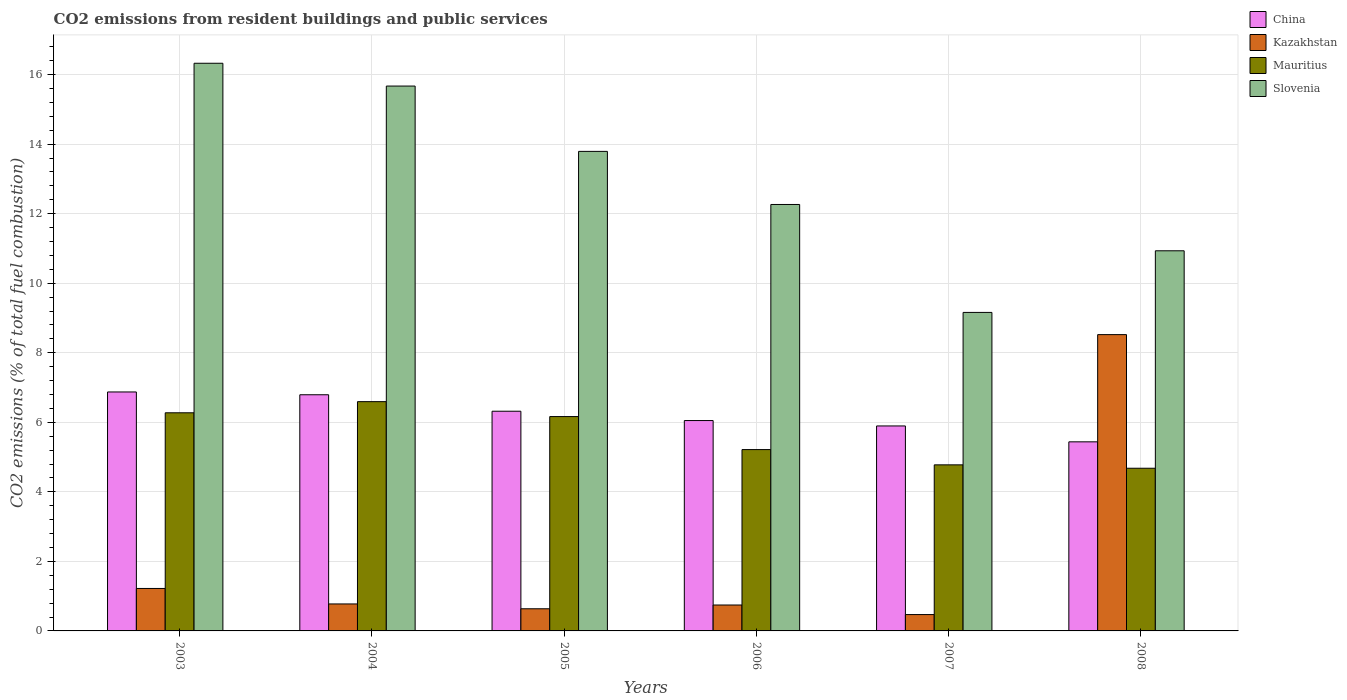How many groups of bars are there?
Your answer should be compact. 6. How many bars are there on the 5th tick from the left?
Your answer should be compact. 4. How many bars are there on the 4th tick from the right?
Your answer should be compact. 4. What is the total CO2 emitted in Mauritius in 2004?
Make the answer very short. 6.59. Across all years, what is the maximum total CO2 emitted in Slovenia?
Give a very brief answer. 16.33. Across all years, what is the minimum total CO2 emitted in Slovenia?
Your answer should be compact. 9.16. In which year was the total CO2 emitted in Kazakhstan minimum?
Keep it short and to the point. 2007. What is the total total CO2 emitted in China in the graph?
Ensure brevity in your answer.  37.36. What is the difference between the total CO2 emitted in Mauritius in 2005 and that in 2008?
Ensure brevity in your answer.  1.49. What is the difference between the total CO2 emitted in Kazakhstan in 2008 and the total CO2 emitted in Mauritius in 2004?
Your answer should be compact. 1.93. What is the average total CO2 emitted in China per year?
Offer a terse response. 6.23. In the year 2005, what is the difference between the total CO2 emitted in China and total CO2 emitted in Kazakhstan?
Keep it short and to the point. 5.68. In how many years, is the total CO2 emitted in Kazakhstan greater than 12.4?
Offer a terse response. 0. What is the ratio of the total CO2 emitted in Slovenia in 2006 to that in 2008?
Offer a terse response. 1.12. Is the total CO2 emitted in Mauritius in 2006 less than that in 2008?
Keep it short and to the point. No. Is the difference between the total CO2 emitted in China in 2004 and 2007 greater than the difference between the total CO2 emitted in Kazakhstan in 2004 and 2007?
Keep it short and to the point. Yes. What is the difference between the highest and the second highest total CO2 emitted in China?
Offer a very short reply. 0.08. What is the difference between the highest and the lowest total CO2 emitted in Slovenia?
Give a very brief answer. 7.17. Is it the case that in every year, the sum of the total CO2 emitted in Slovenia and total CO2 emitted in China is greater than the sum of total CO2 emitted in Kazakhstan and total CO2 emitted in Mauritius?
Provide a succinct answer. Yes. What does the 4th bar from the left in 2005 represents?
Give a very brief answer. Slovenia. What does the 3rd bar from the right in 2004 represents?
Keep it short and to the point. Kazakhstan. Is it the case that in every year, the sum of the total CO2 emitted in Kazakhstan and total CO2 emitted in Slovenia is greater than the total CO2 emitted in China?
Your response must be concise. Yes. Are all the bars in the graph horizontal?
Provide a short and direct response. No. How many years are there in the graph?
Make the answer very short. 6. Does the graph contain grids?
Ensure brevity in your answer.  Yes. What is the title of the graph?
Your answer should be very brief. CO2 emissions from resident buildings and public services. What is the label or title of the Y-axis?
Provide a short and direct response. CO2 emissions (% of total fuel combustion). What is the CO2 emissions (% of total fuel combustion) of China in 2003?
Make the answer very short. 6.87. What is the CO2 emissions (% of total fuel combustion) of Kazakhstan in 2003?
Keep it short and to the point. 1.22. What is the CO2 emissions (% of total fuel combustion) of Mauritius in 2003?
Provide a succinct answer. 6.27. What is the CO2 emissions (% of total fuel combustion) in Slovenia in 2003?
Offer a very short reply. 16.33. What is the CO2 emissions (% of total fuel combustion) of China in 2004?
Ensure brevity in your answer.  6.79. What is the CO2 emissions (% of total fuel combustion) in Kazakhstan in 2004?
Offer a terse response. 0.78. What is the CO2 emissions (% of total fuel combustion) in Mauritius in 2004?
Make the answer very short. 6.59. What is the CO2 emissions (% of total fuel combustion) in Slovenia in 2004?
Your response must be concise. 15.67. What is the CO2 emissions (% of total fuel combustion) of China in 2005?
Offer a very short reply. 6.32. What is the CO2 emissions (% of total fuel combustion) of Kazakhstan in 2005?
Ensure brevity in your answer.  0.64. What is the CO2 emissions (% of total fuel combustion) of Mauritius in 2005?
Make the answer very short. 6.16. What is the CO2 emissions (% of total fuel combustion) of Slovenia in 2005?
Provide a succinct answer. 13.79. What is the CO2 emissions (% of total fuel combustion) in China in 2006?
Your answer should be compact. 6.05. What is the CO2 emissions (% of total fuel combustion) of Kazakhstan in 2006?
Ensure brevity in your answer.  0.75. What is the CO2 emissions (% of total fuel combustion) of Mauritius in 2006?
Provide a succinct answer. 5.21. What is the CO2 emissions (% of total fuel combustion) of Slovenia in 2006?
Your response must be concise. 12.26. What is the CO2 emissions (% of total fuel combustion) of China in 2007?
Ensure brevity in your answer.  5.89. What is the CO2 emissions (% of total fuel combustion) in Kazakhstan in 2007?
Offer a terse response. 0.47. What is the CO2 emissions (% of total fuel combustion) in Mauritius in 2007?
Your answer should be very brief. 4.78. What is the CO2 emissions (% of total fuel combustion) in Slovenia in 2007?
Provide a succinct answer. 9.16. What is the CO2 emissions (% of total fuel combustion) in China in 2008?
Provide a succinct answer. 5.44. What is the CO2 emissions (% of total fuel combustion) of Kazakhstan in 2008?
Ensure brevity in your answer.  8.52. What is the CO2 emissions (% of total fuel combustion) in Mauritius in 2008?
Offer a terse response. 4.68. What is the CO2 emissions (% of total fuel combustion) in Slovenia in 2008?
Provide a short and direct response. 10.93. Across all years, what is the maximum CO2 emissions (% of total fuel combustion) in China?
Keep it short and to the point. 6.87. Across all years, what is the maximum CO2 emissions (% of total fuel combustion) in Kazakhstan?
Give a very brief answer. 8.52. Across all years, what is the maximum CO2 emissions (% of total fuel combustion) in Mauritius?
Ensure brevity in your answer.  6.59. Across all years, what is the maximum CO2 emissions (% of total fuel combustion) in Slovenia?
Provide a succinct answer. 16.33. Across all years, what is the minimum CO2 emissions (% of total fuel combustion) of China?
Offer a very short reply. 5.44. Across all years, what is the minimum CO2 emissions (% of total fuel combustion) of Kazakhstan?
Your answer should be compact. 0.47. Across all years, what is the minimum CO2 emissions (% of total fuel combustion) of Mauritius?
Provide a short and direct response. 4.68. Across all years, what is the minimum CO2 emissions (% of total fuel combustion) of Slovenia?
Make the answer very short. 9.16. What is the total CO2 emissions (% of total fuel combustion) of China in the graph?
Offer a very short reply. 37.36. What is the total CO2 emissions (% of total fuel combustion) of Kazakhstan in the graph?
Provide a short and direct response. 12.37. What is the total CO2 emissions (% of total fuel combustion) in Mauritius in the graph?
Offer a terse response. 33.7. What is the total CO2 emissions (% of total fuel combustion) of Slovenia in the graph?
Keep it short and to the point. 78.14. What is the difference between the CO2 emissions (% of total fuel combustion) of China in 2003 and that in 2004?
Your response must be concise. 0.08. What is the difference between the CO2 emissions (% of total fuel combustion) in Kazakhstan in 2003 and that in 2004?
Offer a very short reply. 0.45. What is the difference between the CO2 emissions (% of total fuel combustion) in Mauritius in 2003 and that in 2004?
Make the answer very short. -0.32. What is the difference between the CO2 emissions (% of total fuel combustion) of Slovenia in 2003 and that in 2004?
Your answer should be compact. 0.66. What is the difference between the CO2 emissions (% of total fuel combustion) in China in 2003 and that in 2005?
Provide a short and direct response. 0.55. What is the difference between the CO2 emissions (% of total fuel combustion) of Kazakhstan in 2003 and that in 2005?
Offer a terse response. 0.58. What is the difference between the CO2 emissions (% of total fuel combustion) in Mauritius in 2003 and that in 2005?
Make the answer very short. 0.11. What is the difference between the CO2 emissions (% of total fuel combustion) in Slovenia in 2003 and that in 2005?
Your response must be concise. 2.53. What is the difference between the CO2 emissions (% of total fuel combustion) of China in 2003 and that in 2006?
Your answer should be compact. 0.82. What is the difference between the CO2 emissions (% of total fuel combustion) of Kazakhstan in 2003 and that in 2006?
Your answer should be very brief. 0.48. What is the difference between the CO2 emissions (% of total fuel combustion) in Mauritius in 2003 and that in 2006?
Your answer should be compact. 1.06. What is the difference between the CO2 emissions (% of total fuel combustion) in Slovenia in 2003 and that in 2006?
Make the answer very short. 4.06. What is the difference between the CO2 emissions (% of total fuel combustion) in China in 2003 and that in 2007?
Keep it short and to the point. 0.98. What is the difference between the CO2 emissions (% of total fuel combustion) in Kazakhstan in 2003 and that in 2007?
Your answer should be very brief. 0.75. What is the difference between the CO2 emissions (% of total fuel combustion) in Mauritius in 2003 and that in 2007?
Ensure brevity in your answer.  1.5. What is the difference between the CO2 emissions (% of total fuel combustion) in Slovenia in 2003 and that in 2007?
Your response must be concise. 7.17. What is the difference between the CO2 emissions (% of total fuel combustion) in China in 2003 and that in 2008?
Your answer should be compact. 1.43. What is the difference between the CO2 emissions (% of total fuel combustion) in Kazakhstan in 2003 and that in 2008?
Offer a terse response. -7.3. What is the difference between the CO2 emissions (% of total fuel combustion) of Mauritius in 2003 and that in 2008?
Offer a very short reply. 1.59. What is the difference between the CO2 emissions (% of total fuel combustion) in Slovenia in 2003 and that in 2008?
Your answer should be very brief. 5.39. What is the difference between the CO2 emissions (% of total fuel combustion) in China in 2004 and that in 2005?
Make the answer very short. 0.47. What is the difference between the CO2 emissions (% of total fuel combustion) in Kazakhstan in 2004 and that in 2005?
Offer a very short reply. 0.14. What is the difference between the CO2 emissions (% of total fuel combustion) of Mauritius in 2004 and that in 2005?
Your response must be concise. 0.43. What is the difference between the CO2 emissions (% of total fuel combustion) in Slovenia in 2004 and that in 2005?
Provide a succinct answer. 1.88. What is the difference between the CO2 emissions (% of total fuel combustion) in China in 2004 and that in 2006?
Offer a very short reply. 0.74. What is the difference between the CO2 emissions (% of total fuel combustion) in Kazakhstan in 2004 and that in 2006?
Provide a short and direct response. 0.03. What is the difference between the CO2 emissions (% of total fuel combustion) in Mauritius in 2004 and that in 2006?
Give a very brief answer. 1.38. What is the difference between the CO2 emissions (% of total fuel combustion) in Slovenia in 2004 and that in 2006?
Ensure brevity in your answer.  3.41. What is the difference between the CO2 emissions (% of total fuel combustion) in China in 2004 and that in 2007?
Your answer should be very brief. 0.9. What is the difference between the CO2 emissions (% of total fuel combustion) in Kazakhstan in 2004 and that in 2007?
Give a very brief answer. 0.31. What is the difference between the CO2 emissions (% of total fuel combustion) of Mauritius in 2004 and that in 2007?
Offer a terse response. 1.82. What is the difference between the CO2 emissions (% of total fuel combustion) in Slovenia in 2004 and that in 2007?
Provide a succinct answer. 6.51. What is the difference between the CO2 emissions (% of total fuel combustion) in China in 2004 and that in 2008?
Give a very brief answer. 1.35. What is the difference between the CO2 emissions (% of total fuel combustion) of Kazakhstan in 2004 and that in 2008?
Give a very brief answer. -7.75. What is the difference between the CO2 emissions (% of total fuel combustion) of Mauritius in 2004 and that in 2008?
Provide a succinct answer. 1.92. What is the difference between the CO2 emissions (% of total fuel combustion) in Slovenia in 2004 and that in 2008?
Your answer should be very brief. 4.74. What is the difference between the CO2 emissions (% of total fuel combustion) in China in 2005 and that in 2006?
Give a very brief answer. 0.27. What is the difference between the CO2 emissions (% of total fuel combustion) of Kazakhstan in 2005 and that in 2006?
Your answer should be compact. -0.11. What is the difference between the CO2 emissions (% of total fuel combustion) of Mauritius in 2005 and that in 2006?
Your answer should be very brief. 0.95. What is the difference between the CO2 emissions (% of total fuel combustion) of Slovenia in 2005 and that in 2006?
Your answer should be compact. 1.53. What is the difference between the CO2 emissions (% of total fuel combustion) in China in 2005 and that in 2007?
Offer a very short reply. 0.42. What is the difference between the CO2 emissions (% of total fuel combustion) in Kazakhstan in 2005 and that in 2007?
Your answer should be compact. 0.17. What is the difference between the CO2 emissions (% of total fuel combustion) in Mauritius in 2005 and that in 2007?
Ensure brevity in your answer.  1.39. What is the difference between the CO2 emissions (% of total fuel combustion) in Slovenia in 2005 and that in 2007?
Make the answer very short. 4.63. What is the difference between the CO2 emissions (% of total fuel combustion) in China in 2005 and that in 2008?
Your answer should be compact. 0.88. What is the difference between the CO2 emissions (% of total fuel combustion) in Kazakhstan in 2005 and that in 2008?
Provide a short and direct response. -7.88. What is the difference between the CO2 emissions (% of total fuel combustion) in Mauritius in 2005 and that in 2008?
Make the answer very short. 1.49. What is the difference between the CO2 emissions (% of total fuel combustion) of Slovenia in 2005 and that in 2008?
Your response must be concise. 2.86. What is the difference between the CO2 emissions (% of total fuel combustion) of China in 2006 and that in 2007?
Make the answer very short. 0.16. What is the difference between the CO2 emissions (% of total fuel combustion) of Kazakhstan in 2006 and that in 2007?
Provide a succinct answer. 0.27. What is the difference between the CO2 emissions (% of total fuel combustion) in Mauritius in 2006 and that in 2007?
Offer a very short reply. 0.44. What is the difference between the CO2 emissions (% of total fuel combustion) of Slovenia in 2006 and that in 2007?
Provide a succinct answer. 3.1. What is the difference between the CO2 emissions (% of total fuel combustion) in China in 2006 and that in 2008?
Your response must be concise. 0.61. What is the difference between the CO2 emissions (% of total fuel combustion) in Kazakhstan in 2006 and that in 2008?
Provide a short and direct response. -7.78. What is the difference between the CO2 emissions (% of total fuel combustion) in Mauritius in 2006 and that in 2008?
Your response must be concise. 0.54. What is the difference between the CO2 emissions (% of total fuel combustion) of Slovenia in 2006 and that in 2008?
Ensure brevity in your answer.  1.33. What is the difference between the CO2 emissions (% of total fuel combustion) of China in 2007 and that in 2008?
Make the answer very short. 0.46. What is the difference between the CO2 emissions (% of total fuel combustion) of Kazakhstan in 2007 and that in 2008?
Give a very brief answer. -8.05. What is the difference between the CO2 emissions (% of total fuel combustion) of Mauritius in 2007 and that in 2008?
Keep it short and to the point. 0.1. What is the difference between the CO2 emissions (% of total fuel combustion) of Slovenia in 2007 and that in 2008?
Your response must be concise. -1.77. What is the difference between the CO2 emissions (% of total fuel combustion) in China in 2003 and the CO2 emissions (% of total fuel combustion) in Kazakhstan in 2004?
Your response must be concise. 6.1. What is the difference between the CO2 emissions (% of total fuel combustion) of China in 2003 and the CO2 emissions (% of total fuel combustion) of Mauritius in 2004?
Your answer should be very brief. 0.28. What is the difference between the CO2 emissions (% of total fuel combustion) in China in 2003 and the CO2 emissions (% of total fuel combustion) in Slovenia in 2004?
Give a very brief answer. -8.8. What is the difference between the CO2 emissions (% of total fuel combustion) of Kazakhstan in 2003 and the CO2 emissions (% of total fuel combustion) of Mauritius in 2004?
Offer a terse response. -5.37. What is the difference between the CO2 emissions (% of total fuel combustion) in Kazakhstan in 2003 and the CO2 emissions (% of total fuel combustion) in Slovenia in 2004?
Make the answer very short. -14.45. What is the difference between the CO2 emissions (% of total fuel combustion) of Mauritius in 2003 and the CO2 emissions (% of total fuel combustion) of Slovenia in 2004?
Your answer should be compact. -9.4. What is the difference between the CO2 emissions (% of total fuel combustion) of China in 2003 and the CO2 emissions (% of total fuel combustion) of Kazakhstan in 2005?
Provide a short and direct response. 6.24. What is the difference between the CO2 emissions (% of total fuel combustion) in China in 2003 and the CO2 emissions (% of total fuel combustion) in Mauritius in 2005?
Your response must be concise. 0.71. What is the difference between the CO2 emissions (% of total fuel combustion) in China in 2003 and the CO2 emissions (% of total fuel combustion) in Slovenia in 2005?
Provide a succinct answer. -6.92. What is the difference between the CO2 emissions (% of total fuel combustion) of Kazakhstan in 2003 and the CO2 emissions (% of total fuel combustion) of Mauritius in 2005?
Ensure brevity in your answer.  -4.94. What is the difference between the CO2 emissions (% of total fuel combustion) of Kazakhstan in 2003 and the CO2 emissions (% of total fuel combustion) of Slovenia in 2005?
Your response must be concise. -12.57. What is the difference between the CO2 emissions (% of total fuel combustion) of Mauritius in 2003 and the CO2 emissions (% of total fuel combustion) of Slovenia in 2005?
Keep it short and to the point. -7.52. What is the difference between the CO2 emissions (% of total fuel combustion) in China in 2003 and the CO2 emissions (% of total fuel combustion) in Kazakhstan in 2006?
Your answer should be compact. 6.13. What is the difference between the CO2 emissions (% of total fuel combustion) of China in 2003 and the CO2 emissions (% of total fuel combustion) of Mauritius in 2006?
Keep it short and to the point. 1.66. What is the difference between the CO2 emissions (% of total fuel combustion) of China in 2003 and the CO2 emissions (% of total fuel combustion) of Slovenia in 2006?
Your answer should be compact. -5.39. What is the difference between the CO2 emissions (% of total fuel combustion) of Kazakhstan in 2003 and the CO2 emissions (% of total fuel combustion) of Mauritius in 2006?
Make the answer very short. -3.99. What is the difference between the CO2 emissions (% of total fuel combustion) in Kazakhstan in 2003 and the CO2 emissions (% of total fuel combustion) in Slovenia in 2006?
Your answer should be compact. -11.04. What is the difference between the CO2 emissions (% of total fuel combustion) in Mauritius in 2003 and the CO2 emissions (% of total fuel combustion) in Slovenia in 2006?
Offer a very short reply. -5.99. What is the difference between the CO2 emissions (% of total fuel combustion) of China in 2003 and the CO2 emissions (% of total fuel combustion) of Kazakhstan in 2007?
Provide a succinct answer. 6.4. What is the difference between the CO2 emissions (% of total fuel combustion) of China in 2003 and the CO2 emissions (% of total fuel combustion) of Mauritius in 2007?
Offer a very short reply. 2.1. What is the difference between the CO2 emissions (% of total fuel combustion) in China in 2003 and the CO2 emissions (% of total fuel combustion) in Slovenia in 2007?
Your response must be concise. -2.29. What is the difference between the CO2 emissions (% of total fuel combustion) of Kazakhstan in 2003 and the CO2 emissions (% of total fuel combustion) of Mauritius in 2007?
Keep it short and to the point. -3.55. What is the difference between the CO2 emissions (% of total fuel combustion) in Kazakhstan in 2003 and the CO2 emissions (% of total fuel combustion) in Slovenia in 2007?
Keep it short and to the point. -7.94. What is the difference between the CO2 emissions (% of total fuel combustion) of Mauritius in 2003 and the CO2 emissions (% of total fuel combustion) of Slovenia in 2007?
Offer a terse response. -2.89. What is the difference between the CO2 emissions (% of total fuel combustion) in China in 2003 and the CO2 emissions (% of total fuel combustion) in Kazakhstan in 2008?
Ensure brevity in your answer.  -1.65. What is the difference between the CO2 emissions (% of total fuel combustion) in China in 2003 and the CO2 emissions (% of total fuel combustion) in Mauritius in 2008?
Offer a very short reply. 2.19. What is the difference between the CO2 emissions (% of total fuel combustion) of China in 2003 and the CO2 emissions (% of total fuel combustion) of Slovenia in 2008?
Provide a short and direct response. -4.06. What is the difference between the CO2 emissions (% of total fuel combustion) of Kazakhstan in 2003 and the CO2 emissions (% of total fuel combustion) of Mauritius in 2008?
Your answer should be compact. -3.46. What is the difference between the CO2 emissions (% of total fuel combustion) in Kazakhstan in 2003 and the CO2 emissions (% of total fuel combustion) in Slovenia in 2008?
Offer a very short reply. -9.71. What is the difference between the CO2 emissions (% of total fuel combustion) in Mauritius in 2003 and the CO2 emissions (% of total fuel combustion) in Slovenia in 2008?
Provide a short and direct response. -4.66. What is the difference between the CO2 emissions (% of total fuel combustion) of China in 2004 and the CO2 emissions (% of total fuel combustion) of Kazakhstan in 2005?
Offer a terse response. 6.16. What is the difference between the CO2 emissions (% of total fuel combustion) of China in 2004 and the CO2 emissions (% of total fuel combustion) of Mauritius in 2005?
Make the answer very short. 0.63. What is the difference between the CO2 emissions (% of total fuel combustion) of China in 2004 and the CO2 emissions (% of total fuel combustion) of Slovenia in 2005?
Offer a terse response. -7. What is the difference between the CO2 emissions (% of total fuel combustion) of Kazakhstan in 2004 and the CO2 emissions (% of total fuel combustion) of Mauritius in 2005?
Keep it short and to the point. -5.39. What is the difference between the CO2 emissions (% of total fuel combustion) of Kazakhstan in 2004 and the CO2 emissions (% of total fuel combustion) of Slovenia in 2005?
Provide a succinct answer. -13.02. What is the difference between the CO2 emissions (% of total fuel combustion) in Mauritius in 2004 and the CO2 emissions (% of total fuel combustion) in Slovenia in 2005?
Give a very brief answer. -7.2. What is the difference between the CO2 emissions (% of total fuel combustion) in China in 2004 and the CO2 emissions (% of total fuel combustion) in Kazakhstan in 2006?
Provide a short and direct response. 6.05. What is the difference between the CO2 emissions (% of total fuel combustion) in China in 2004 and the CO2 emissions (% of total fuel combustion) in Mauritius in 2006?
Make the answer very short. 1.58. What is the difference between the CO2 emissions (% of total fuel combustion) of China in 2004 and the CO2 emissions (% of total fuel combustion) of Slovenia in 2006?
Provide a short and direct response. -5.47. What is the difference between the CO2 emissions (% of total fuel combustion) in Kazakhstan in 2004 and the CO2 emissions (% of total fuel combustion) in Mauritius in 2006?
Ensure brevity in your answer.  -4.44. What is the difference between the CO2 emissions (% of total fuel combustion) in Kazakhstan in 2004 and the CO2 emissions (% of total fuel combustion) in Slovenia in 2006?
Provide a short and direct response. -11.49. What is the difference between the CO2 emissions (% of total fuel combustion) of Mauritius in 2004 and the CO2 emissions (% of total fuel combustion) of Slovenia in 2006?
Offer a very short reply. -5.67. What is the difference between the CO2 emissions (% of total fuel combustion) of China in 2004 and the CO2 emissions (% of total fuel combustion) of Kazakhstan in 2007?
Offer a very short reply. 6.32. What is the difference between the CO2 emissions (% of total fuel combustion) in China in 2004 and the CO2 emissions (% of total fuel combustion) in Mauritius in 2007?
Your answer should be very brief. 2.02. What is the difference between the CO2 emissions (% of total fuel combustion) in China in 2004 and the CO2 emissions (% of total fuel combustion) in Slovenia in 2007?
Your response must be concise. -2.37. What is the difference between the CO2 emissions (% of total fuel combustion) of Kazakhstan in 2004 and the CO2 emissions (% of total fuel combustion) of Mauritius in 2007?
Ensure brevity in your answer.  -4. What is the difference between the CO2 emissions (% of total fuel combustion) of Kazakhstan in 2004 and the CO2 emissions (% of total fuel combustion) of Slovenia in 2007?
Offer a terse response. -8.38. What is the difference between the CO2 emissions (% of total fuel combustion) in Mauritius in 2004 and the CO2 emissions (% of total fuel combustion) in Slovenia in 2007?
Your response must be concise. -2.57. What is the difference between the CO2 emissions (% of total fuel combustion) of China in 2004 and the CO2 emissions (% of total fuel combustion) of Kazakhstan in 2008?
Ensure brevity in your answer.  -1.73. What is the difference between the CO2 emissions (% of total fuel combustion) of China in 2004 and the CO2 emissions (% of total fuel combustion) of Mauritius in 2008?
Your response must be concise. 2.11. What is the difference between the CO2 emissions (% of total fuel combustion) of China in 2004 and the CO2 emissions (% of total fuel combustion) of Slovenia in 2008?
Provide a short and direct response. -4.14. What is the difference between the CO2 emissions (% of total fuel combustion) in Kazakhstan in 2004 and the CO2 emissions (% of total fuel combustion) in Mauritius in 2008?
Ensure brevity in your answer.  -3.9. What is the difference between the CO2 emissions (% of total fuel combustion) in Kazakhstan in 2004 and the CO2 emissions (% of total fuel combustion) in Slovenia in 2008?
Ensure brevity in your answer.  -10.16. What is the difference between the CO2 emissions (% of total fuel combustion) of Mauritius in 2004 and the CO2 emissions (% of total fuel combustion) of Slovenia in 2008?
Your answer should be compact. -4.34. What is the difference between the CO2 emissions (% of total fuel combustion) of China in 2005 and the CO2 emissions (% of total fuel combustion) of Kazakhstan in 2006?
Make the answer very short. 5.57. What is the difference between the CO2 emissions (% of total fuel combustion) in China in 2005 and the CO2 emissions (% of total fuel combustion) in Mauritius in 2006?
Your response must be concise. 1.1. What is the difference between the CO2 emissions (% of total fuel combustion) in China in 2005 and the CO2 emissions (% of total fuel combustion) in Slovenia in 2006?
Give a very brief answer. -5.95. What is the difference between the CO2 emissions (% of total fuel combustion) of Kazakhstan in 2005 and the CO2 emissions (% of total fuel combustion) of Mauritius in 2006?
Your response must be concise. -4.58. What is the difference between the CO2 emissions (% of total fuel combustion) of Kazakhstan in 2005 and the CO2 emissions (% of total fuel combustion) of Slovenia in 2006?
Provide a short and direct response. -11.63. What is the difference between the CO2 emissions (% of total fuel combustion) in Mauritius in 2005 and the CO2 emissions (% of total fuel combustion) in Slovenia in 2006?
Provide a succinct answer. -6.1. What is the difference between the CO2 emissions (% of total fuel combustion) of China in 2005 and the CO2 emissions (% of total fuel combustion) of Kazakhstan in 2007?
Provide a short and direct response. 5.85. What is the difference between the CO2 emissions (% of total fuel combustion) in China in 2005 and the CO2 emissions (% of total fuel combustion) in Mauritius in 2007?
Your response must be concise. 1.54. What is the difference between the CO2 emissions (% of total fuel combustion) of China in 2005 and the CO2 emissions (% of total fuel combustion) of Slovenia in 2007?
Give a very brief answer. -2.84. What is the difference between the CO2 emissions (% of total fuel combustion) of Kazakhstan in 2005 and the CO2 emissions (% of total fuel combustion) of Mauritius in 2007?
Offer a very short reply. -4.14. What is the difference between the CO2 emissions (% of total fuel combustion) of Kazakhstan in 2005 and the CO2 emissions (% of total fuel combustion) of Slovenia in 2007?
Your answer should be very brief. -8.52. What is the difference between the CO2 emissions (% of total fuel combustion) of Mauritius in 2005 and the CO2 emissions (% of total fuel combustion) of Slovenia in 2007?
Your response must be concise. -3. What is the difference between the CO2 emissions (% of total fuel combustion) of China in 2005 and the CO2 emissions (% of total fuel combustion) of Kazakhstan in 2008?
Offer a terse response. -2.2. What is the difference between the CO2 emissions (% of total fuel combustion) of China in 2005 and the CO2 emissions (% of total fuel combustion) of Mauritius in 2008?
Give a very brief answer. 1.64. What is the difference between the CO2 emissions (% of total fuel combustion) of China in 2005 and the CO2 emissions (% of total fuel combustion) of Slovenia in 2008?
Your response must be concise. -4.61. What is the difference between the CO2 emissions (% of total fuel combustion) of Kazakhstan in 2005 and the CO2 emissions (% of total fuel combustion) of Mauritius in 2008?
Your response must be concise. -4.04. What is the difference between the CO2 emissions (% of total fuel combustion) in Kazakhstan in 2005 and the CO2 emissions (% of total fuel combustion) in Slovenia in 2008?
Your answer should be compact. -10.3. What is the difference between the CO2 emissions (% of total fuel combustion) of Mauritius in 2005 and the CO2 emissions (% of total fuel combustion) of Slovenia in 2008?
Make the answer very short. -4.77. What is the difference between the CO2 emissions (% of total fuel combustion) in China in 2006 and the CO2 emissions (% of total fuel combustion) in Kazakhstan in 2007?
Make the answer very short. 5.58. What is the difference between the CO2 emissions (% of total fuel combustion) of China in 2006 and the CO2 emissions (% of total fuel combustion) of Mauritius in 2007?
Give a very brief answer. 1.27. What is the difference between the CO2 emissions (% of total fuel combustion) of China in 2006 and the CO2 emissions (% of total fuel combustion) of Slovenia in 2007?
Provide a short and direct response. -3.11. What is the difference between the CO2 emissions (% of total fuel combustion) in Kazakhstan in 2006 and the CO2 emissions (% of total fuel combustion) in Mauritius in 2007?
Your response must be concise. -4.03. What is the difference between the CO2 emissions (% of total fuel combustion) of Kazakhstan in 2006 and the CO2 emissions (% of total fuel combustion) of Slovenia in 2007?
Keep it short and to the point. -8.41. What is the difference between the CO2 emissions (% of total fuel combustion) of Mauritius in 2006 and the CO2 emissions (% of total fuel combustion) of Slovenia in 2007?
Provide a short and direct response. -3.95. What is the difference between the CO2 emissions (% of total fuel combustion) in China in 2006 and the CO2 emissions (% of total fuel combustion) in Kazakhstan in 2008?
Make the answer very short. -2.47. What is the difference between the CO2 emissions (% of total fuel combustion) of China in 2006 and the CO2 emissions (% of total fuel combustion) of Mauritius in 2008?
Provide a short and direct response. 1.37. What is the difference between the CO2 emissions (% of total fuel combustion) of China in 2006 and the CO2 emissions (% of total fuel combustion) of Slovenia in 2008?
Offer a very short reply. -4.88. What is the difference between the CO2 emissions (% of total fuel combustion) of Kazakhstan in 2006 and the CO2 emissions (% of total fuel combustion) of Mauritius in 2008?
Offer a very short reply. -3.93. What is the difference between the CO2 emissions (% of total fuel combustion) in Kazakhstan in 2006 and the CO2 emissions (% of total fuel combustion) in Slovenia in 2008?
Make the answer very short. -10.19. What is the difference between the CO2 emissions (% of total fuel combustion) in Mauritius in 2006 and the CO2 emissions (% of total fuel combustion) in Slovenia in 2008?
Your answer should be very brief. -5.72. What is the difference between the CO2 emissions (% of total fuel combustion) of China in 2007 and the CO2 emissions (% of total fuel combustion) of Kazakhstan in 2008?
Your answer should be compact. -2.63. What is the difference between the CO2 emissions (% of total fuel combustion) in China in 2007 and the CO2 emissions (% of total fuel combustion) in Mauritius in 2008?
Ensure brevity in your answer.  1.22. What is the difference between the CO2 emissions (% of total fuel combustion) in China in 2007 and the CO2 emissions (% of total fuel combustion) in Slovenia in 2008?
Make the answer very short. -5.04. What is the difference between the CO2 emissions (% of total fuel combustion) in Kazakhstan in 2007 and the CO2 emissions (% of total fuel combustion) in Mauritius in 2008?
Your answer should be compact. -4.21. What is the difference between the CO2 emissions (% of total fuel combustion) in Kazakhstan in 2007 and the CO2 emissions (% of total fuel combustion) in Slovenia in 2008?
Keep it short and to the point. -10.46. What is the difference between the CO2 emissions (% of total fuel combustion) of Mauritius in 2007 and the CO2 emissions (% of total fuel combustion) of Slovenia in 2008?
Provide a short and direct response. -6.16. What is the average CO2 emissions (% of total fuel combustion) of China per year?
Keep it short and to the point. 6.23. What is the average CO2 emissions (% of total fuel combustion) in Kazakhstan per year?
Offer a very short reply. 2.06. What is the average CO2 emissions (% of total fuel combustion) in Mauritius per year?
Keep it short and to the point. 5.62. What is the average CO2 emissions (% of total fuel combustion) of Slovenia per year?
Your answer should be very brief. 13.02. In the year 2003, what is the difference between the CO2 emissions (% of total fuel combustion) in China and CO2 emissions (% of total fuel combustion) in Kazakhstan?
Give a very brief answer. 5.65. In the year 2003, what is the difference between the CO2 emissions (% of total fuel combustion) of China and CO2 emissions (% of total fuel combustion) of Mauritius?
Keep it short and to the point. 0.6. In the year 2003, what is the difference between the CO2 emissions (% of total fuel combustion) of China and CO2 emissions (% of total fuel combustion) of Slovenia?
Make the answer very short. -9.45. In the year 2003, what is the difference between the CO2 emissions (% of total fuel combustion) of Kazakhstan and CO2 emissions (% of total fuel combustion) of Mauritius?
Offer a very short reply. -5.05. In the year 2003, what is the difference between the CO2 emissions (% of total fuel combustion) in Kazakhstan and CO2 emissions (% of total fuel combustion) in Slovenia?
Give a very brief answer. -15.1. In the year 2003, what is the difference between the CO2 emissions (% of total fuel combustion) of Mauritius and CO2 emissions (% of total fuel combustion) of Slovenia?
Give a very brief answer. -10.05. In the year 2004, what is the difference between the CO2 emissions (% of total fuel combustion) of China and CO2 emissions (% of total fuel combustion) of Kazakhstan?
Make the answer very short. 6.02. In the year 2004, what is the difference between the CO2 emissions (% of total fuel combustion) of China and CO2 emissions (% of total fuel combustion) of Mauritius?
Provide a succinct answer. 0.2. In the year 2004, what is the difference between the CO2 emissions (% of total fuel combustion) in China and CO2 emissions (% of total fuel combustion) in Slovenia?
Your answer should be very brief. -8.88. In the year 2004, what is the difference between the CO2 emissions (% of total fuel combustion) of Kazakhstan and CO2 emissions (% of total fuel combustion) of Mauritius?
Your response must be concise. -5.82. In the year 2004, what is the difference between the CO2 emissions (% of total fuel combustion) of Kazakhstan and CO2 emissions (% of total fuel combustion) of Slovenia?
Ensure brevity in your answer.  -14.89. In the year 2004, what is the difference between the CO2 emissions (% of total fuel combustion) of Mauritius and CO2 emissions (% of total fuel combustion) of Slovenia?
Make the answer very short. -9.08. In the year 2005, what is the difference between the CO2 emissions (% of total fuel combustion) of China and CO2 emissions (% of total fuel combustion) of Kazakhstan?
Keep it short and to the point. 5.68. In the year 2005, what is the difference between the CO2 emissions (% of total fuel combustion) of China and CO2 emissions (% of total fuel combustion) of Mauritius?
Provide a short and direct response. 0.15. In the year 2005, what is the difference between the CO2 emissions (% of total fuel combustion) in China and CO2 emissions (% of total fuel combustion) in Slovenia?
Ensure brevity in your answer.  -7.47. In the year 2005, what is the difference between the CO2 emissions (% of total fuel combustion) in Kazakhstan and CO2 emissions (% of total fuel combustion) in Mauritius?
Provide a succinct answer. -5.53. In the year 2005, what is the difference between the CO2 emissions (% of total fuel combustion) of Kazakhstan and CO2 emissions (% of total fuel combustion) of Slovenia?
Provide a succinct answer. -13.15. In the year 2005, what is the difference between the CO2 emissions (% of total fuel combustion) of Mauritius and CO2 emissions (% of total fuel combustion) of Slovenia?
Give a very brief answer. -7.63. In the year 2006, what is the difference between the CO2 emissions (% of total fuel combustion) of China and CO2 emissions (% of total fuel combustion) of Kazakhstan?
Offer a terse response. 5.3. In the year 2006, what is the difference between the CO2 emissions (% of total fuel combustion) in China and CO2 emissions (% of total fuel combustion) in Mauritius?
Offer a very short reply. 0.83. In the year 2006, what is the difference between the CO2 emissions (% of total fuel combustion) in China and CO2 emissions (% of total fuel combustion) in Slovenia?
Give a very brief answer. -6.21. In the year 2006, what is the difference between the CO2 emissions (% of total fuel combustion) of Kazakhstan and CO2 emissions (% of total fuel combustion) of Mauritius?
Provide a succinct answer. -4.47. In the year 2006, what is the difference between the CO2 emissions (% of total fuel combustion) of Kazakhstan and CO2 emissions (% of total fuel combustion) of Slovenia?
Provide a succinct answer. -11.52. In the year 2006, what is the difference between the CO2 emissions (% of total fuel combustion) in Mauritius and CO2 emissions (% of total fuel combustion) in Slovenia?
Give a very brief answer. -7.05. In the year 2007, what is the difference between the CO2 emissions (% of total fuel combustion) in China and CO2 emissions (% of total fuel combustion) in Kazakhstan?
Your answer should be very brief. 5.42. In the year 2007, what is the difference between the CO2 emissions (% of total fuel combustion) of China and CO2 emissions (% of total fuel combustion) of Mauritius?
Offer a terse response. 1.12. In the year 2007, what is the difference between the CO2 emissions (% of total fuel combustion) of China and CO2 emissions (% of total fuel combustion) of Slovenia?
Provide a succinct answer. -3.27. In the year 2007, what is the difference between the CO2 emissions (% of total fuel combustion) of Kazakhstan and CO2 emissions (% of total fuel combustion) of Mauritius?
Offer a terse response. -4.31. In the year 2007, what is the difference between the CO2 emissions (% of total fuel combustion) in Kazakhstan and CO2 emissions (% of total fuel combustion) in Slovenia?
Your response must be concise. -8.69. In the year 2007, what is the difference between the CO2 emissions (% of total fuel combustion) in Mauritius and CO2 emissions (% of total fuel combustion) in Slovenia?
Ensure brevity in your answer.  -4.38. In the year 2008, what is the difference between the CO2 emissions (% of total fuel combustion) of China and CO2 emissions (% of total fuel combustion) of Kazakhstan?
Give a very brief answer. -3.08. In the year 2008, what is the difference between the CO2 emissions (% of total fuel combustion) of China and CO2 emissions (% of total fuel combustion) of Mauritius?
Keep it short and to the point. 0.76. In the year 2008, what is the difference between the CO2 emissions (% of total fuel combustion) of China and CO2 emissions (% of total fuel combustion) of Slovenia?
Offer a very short reply. -5.49. In the year 2008, what is the difference between the CO2 emissions (% of total fuel combustion) in Kazakhstan and CO2 emissions (% of total fuel combustion) in Mauritius?
Make the answer very short. 3.84. In the year 2008, what is the difference between the CO2 emissions (% of total fuel combustion) in Kazakhstan and CO2 emissions (% of total fuel combustion) in Slovenia?
Offer a very short reply. -2.41. In the year 2008, what is the difference between the CO2 emissions (% of total fuel combustion) in Mauritius and CO2 emissions (% of total fuel combustion) in Slovenia?
Your answer should be compact. -6.25. What is the ratio of the CO2 emissions (% of total fuel combustion) in China in 2003 to that in 2004?
Provide a succinct answer. 1.01. What is the ratio of the CO2 emissions (% of total fuel combustion) in Kazakhstan in 2003 to that in 2004?
Give a very brief answer. 1.57. What is the ratio of the CO2 emissions (% of total fuel combustion) in Mauritius in 2003 to that in 2004?
Keep it short and to the point. 0.95. What is the ratio of the CO2 emissions (% of total fuel combustion) in Slovenia in 2003 to that in 2004?
Your answer should be compact. 1.04. What is the ratio of the CO2 emissions (% of total fuel combustion) in China in 2003 to that in 2005?
Your response must be concise. 1.09. What is the ratio of the CO2 emissions (% of total fuel combustion) in Kazakhstan in 2003 to that in 2005?
Give a very brief answer. 1.92. What is the ratio of the CO2 emissions (% of total fuel combustion) in Mauritius in 2003 to that in 2005?
Give a very brief answer. 1.02. What is the ratio of the CO2 emissions (% of total fuel combustion) in Slovenia in 2003 to that in 2005?
Your response must be concise. 1.18. What is the ratio of the CO2 emissions (% of total fuel combustion) of China in 2003 to that in 2006?
Give a very brief answer. 1.14. What is the ratio of the CO2 emissions (% of total fuel combustion) of Kazakhstan in 2003 to that in 2006?
Keep it short and to the point. 1.64. What is the ratio of the CO2 emissions (% of total fuel combustion) in Mauritius in 2003 to that in 2006?
Offer a terse response. 1.2. What is the ratio of the CO2 emissions (% of total fuel combustion) in Slovenia in 2003 to that in 2006?
Provide a short and direct response. 1.33. What is the ratio of the CO2 emissions (% of total fuel combustion) in China in 2003 to that in 2007?
Provide a succinct answer. 1.17. What is the ratio of the CO2 emissions (% of total fuel combustion) of Kazakhstan in 2003 to that in 2007?
Your answer should be very brief. 2.6. What is the ratio of the CO2 emissions (% of total fuel combustion) in Mauritius in 2003 to that in 2007?
Offer a very short reply. 1.31. What is the ratio of the CO2 emissions (% of total fuel combustion) in Slovenia in 2003 to that in 2007?
Your answer should be very brief. 1.78. What is the ratio of the CO2 emissions (% of total fuel combustion) of China in 2003 to that in 2008?
Provide a succinct answer. 1.26. What is the ratio of the CO2 emissions (% of total fuel combustion) of Kazakhstan in 2003 to that in 2008?
Make the answer very short. 0.14. What is the ratio of the CO2 emissions (% of total fuel combustion) in Mauritius in 2003 to that in 2008?
Make the answer very short. 1.34. What is the ratio of the CO2 emissions (% of total fuel combustion) in Slovenia in 2003 to that in 2008?
Offer a terse response. 1.49. What is the ratio of the CO2 emissions (% of total fuel combustion) in China in 2004 to that in 2005?
Give a very brief answer. 1.07. What is the ratio of the CO2 emissions (% of total fuel combustion) of Kazakhstan in 2004 to that in 2005?
Give a very brief answer. 1.22. What is the ratio of the CO2 emissions (% of total fuel combustion) in Mauritius in 2004 to that in 2005?
Keep it short and to the point. 1.07. What is the ratio of the CO2 emissions (% of total fuel combustion) of Slovenia in 2004 to that in 2005?
Your response must be concise. 1.14. What is the ratio of the CO2 emissions (% of total fuel combustion) in China in 2004 to that in 2006?
Provide a succinct answer. 1.12. What is the ratio of the CO2 emissions (% of total fuel combustion) in Kazakhstan in 2004 to that in 2006?
Keep it short and to the point. 1.04. What is the ratio of the CO2 emissions (% of total fuel combustion) of Mauritius in 2004 to that in 2006?
Make the answer very short. 1.26. What is the ratio of the CO2 emissions (% of total fuel combustion) in Slovenia in 2004 to that in 2006?
Provide a succinct answer. 1.28. What is the ratio of the CO2 emissions (% of total fuel combustion) of China in 2004 to that in 2007?
Offer a terse response. 1.15. What is the ratio of the CO2 emissions (% of total fuel combustion) in Kazakhstan in 2004 to that in 2007?
Give a very brief answer. 1.65. What is the ratio of the CO2 emissions (% of total fuel combustion) in Mauritius in 2004 to that in 2007?
Your response must be concise. 1.38. What is the ratio of the CO2 emissions (% of total fuel combustion) of Slovenia in 2004 to that in 2007?
Provide a short and direct response. 1.71. What is the ratio of the CO2 emissions (% of total fuel combustion) in China in 2004 to that in 2008?
Make the answer very short. 1.25. What is the ratio of the CO2 emissions (% of total fuel combustion) of Kazakhstan in 2004 to that in 2008?
Provide a succinct answer. 0.09. What is the ratio of the CO2 emissions (% of total fuel combustion) in Mauritius in 2004 to that in 2008?
Your answer should be compact. 1.41. What is the ratio of the CO2 emissions (% of total fuel combustion) of Slovenia in 2004 to that in 2008?
Your response must be concise. 1.43. What is the ratio of the CO2 emissions (% of total fuel combustion) in China in 2005 to that in 2006?
Make the answer very short. 1.04. What is the ratio of the CO2 emissions (% of total fuel combustion) of Kazakhstan in 2005 to that in 2006?
Give a very brief answer. 0.85. What is the ratio of the CO2 emissions (% of total fuel combustion) of Mauritius in 2005 to that in 2006?
Your answer should be very brief. 1.18. What is the ratio of the CO2 emissions (% of total fuel combustion) of Slovenia in 2005 to that in 2006?
Provide a short and direct response. 1.12. What is the ratio of the CO2 emissions (% of total fuel combustion) in China in 2005 to that in 2007?
Your response must be concise. 1.07. What is the ratio of the CO2 emissions (% of total fuel combustion) of Kazakhstan in 2005 to that in 2007?
Make the answer very short. 1.35. What is the ratio of the CO2 emissions (% of total fuel combustion) of Mauritius in 2005 to that in 2007?
Provide a short and direct response. 1.29. What is the ratio of the CO2 emissions (% of total fuel combustion) of Slovenia in 2005 to that in 2007?
Your response must be concise. 1.51. What is the ratio of the CO2 emissions (% of total fuel combustion) in China in 2005 to that in 2008?
Your response must be concise. 1.16. What is the ratio of the CO2 emissions (% of total fuel combustion) in Kazakhstan in 2005 to that in 2008?
Ensure brevity in your answer.  0.07. What is the ratio of the CO2 emissions (% of total fuel combustion) in Mauritius in 2005 to that in 2008?
Your response must be concise. 1.32. What is the ratio of the CO2 emissions (% of total fuel combustion) in Slovenia in 2005 to that in 2008?
Keep it short and to the point. 1.26. What is the ratio of the CO2 emissions (% of total fuel combustion) of China in 2006 to that in 2007?
Offer a terse response. 1.03. What is the ratio of the CO2 emissions (% of total fuel combustion) of Kazakhstan in 2006 to that in 2007?
Offer a terse response. 1.58. What is the ratio of the CO2 emissions (% of total fuel combustion) in Mauritius in 2006 to that in 2007?
Your response must be concise. 1.09. What is the ratio of the CO2 emissions (% of total fuel combustion) in Slovenia in 2006 to that in 2007?
Keep it short and to the point. 1.34. What is the ratio of the CO2 emissions (% of total fuel combustion) of China in 2006 to that in 2008?
Provide a short and direct response. 1.11. What is the ratio of the CO2 emissions (% of total fuel combustion) in Kazakhstan in 2006 to that in 2008?
Give a very brief answer. 0.09. What is the ratio of the CO2 emissions (% of total fuel combustion) of Mauritius in 2006 to that in 2008?
Your answer should be very brief. 1.11. What is the ratio of the CO2 emissions (% of total fuel combustion) in Slovenia in 2006 to that in 2008?
Your answer should be very brief. 1.12. What is the ratio of the CO2 emissions (% of total fuel combustion) in China in 2007 to that in 2008?
Your answer should be compact. 1.08. What is the ratio of the CO2 emissions (% of total fuel combustion) of Kazakhstan in 2007 to that in 2008?
Make the answer very short. 0.06. What is the ratio of the CO2 emissions (% of total fuel combustion) in Mauritius in 2007 to that in 2008?
Your answer should be very brief. 1.02. What is the ratio of the CO2 emissions (% of total fuel combustion) of Slovenia in 2007 to that in 2008?
Give a very brief answer. 0.84. What is the difference between the highest and the second highest CO2 emissions (% of total fuel combustion) of China?
Offer a terse response. 0.08. What is the difference between the highest and the second highest CO2 emissions (% of total fuel combustion) of Kazakhstan?
Your answer should be very brief. 7.3. What is the difference between the highest and the second highest CO2 emissions (% of total fuel combustion) in Mauritius?
Ensure brevity in your answer.  0.32. What is the difference between the highest and the second highest CO2 emissions (% of total fuel combustion) in Slovenia?
Ensure brevity in your answer.  0.66. What is the difference between the highest and the lowest CO2 emissions (% of total fuel combustion) of China?
Provide a succinct answer. 1.43. What is the difference between the highest and the lowest CO2 emissions (% of total fuel combustion) in Kazakhstan?
Your response must be concise. 8.05. What is the difference between the highest and the lowest CO2 emissions (% of total fuel combustion) of Mauritius?
Give a very brief answer. 1.92. What is the difference between the highest and the lowest CO2 emissions (% of total fuel combustion) of Slovenia?
Provide a succinct answer. 7.17. 